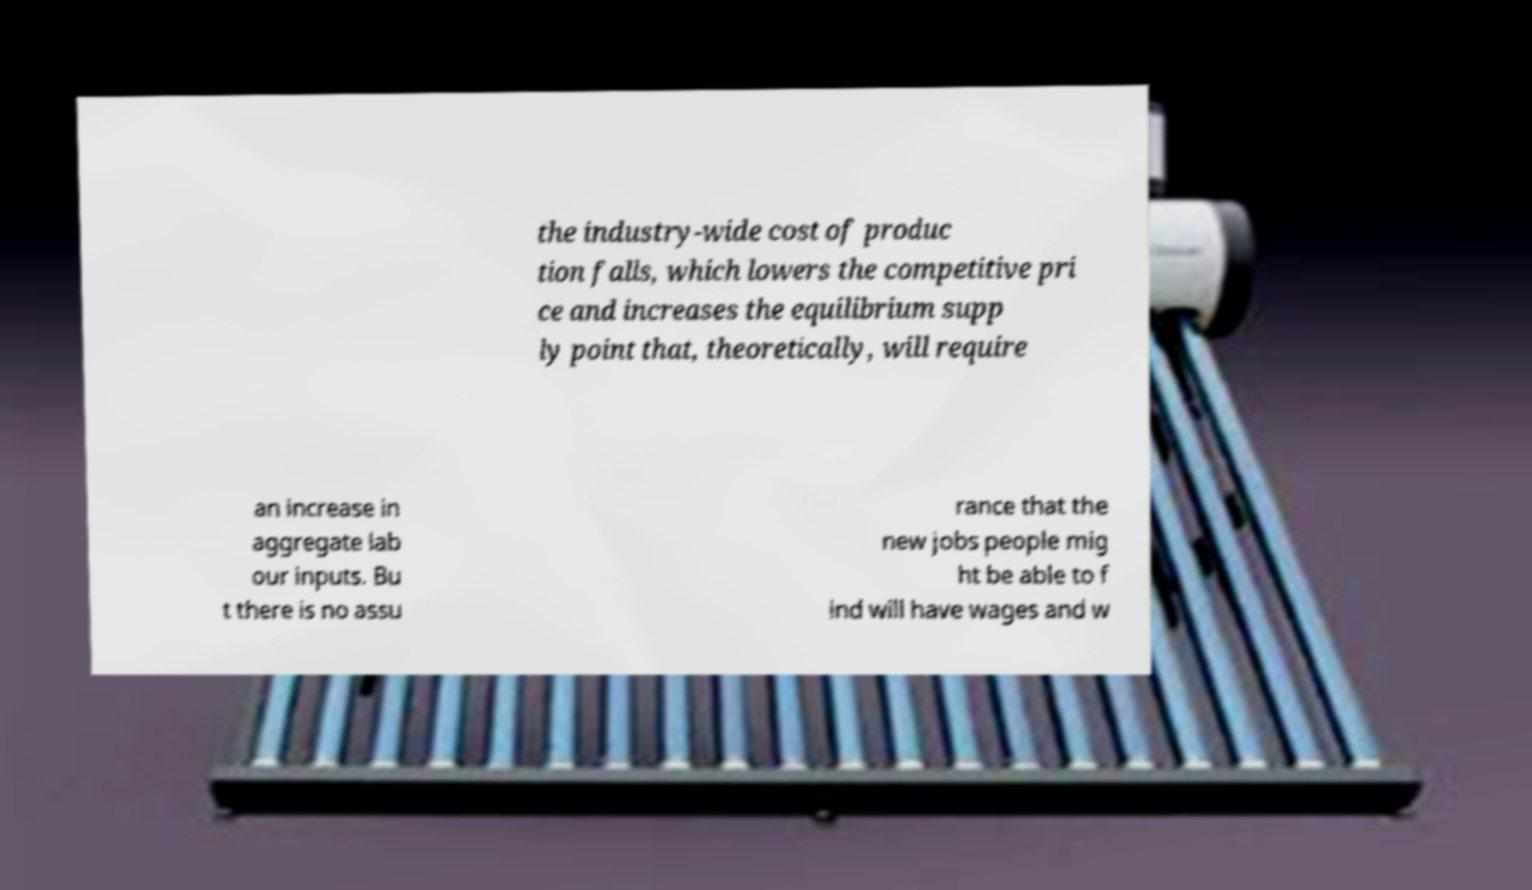Could you assist in decoding the text presented in this image and type it out clearly? the industry-wide cost of produc tion falls, which lowers the competitive pri ce and increases the equilibrium supp ly point that, theoretically, will require an increase in aggregate lab our inputs. Bu t there is no assu rance that the new jobs people mig ht be able to f ind will have wages and w 